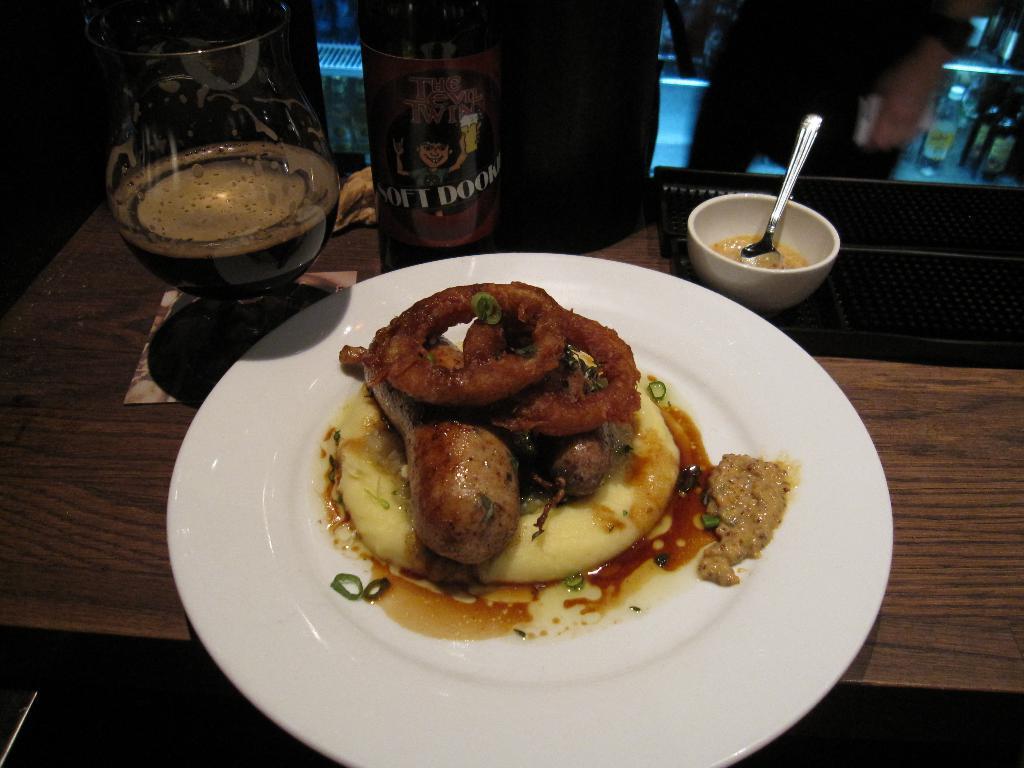Could you give a brief overview of what you see in this image? In this picture I can see there is food served in a plate and in the backdrop I can see there is a beer bottle and there are few people standing near the table. 